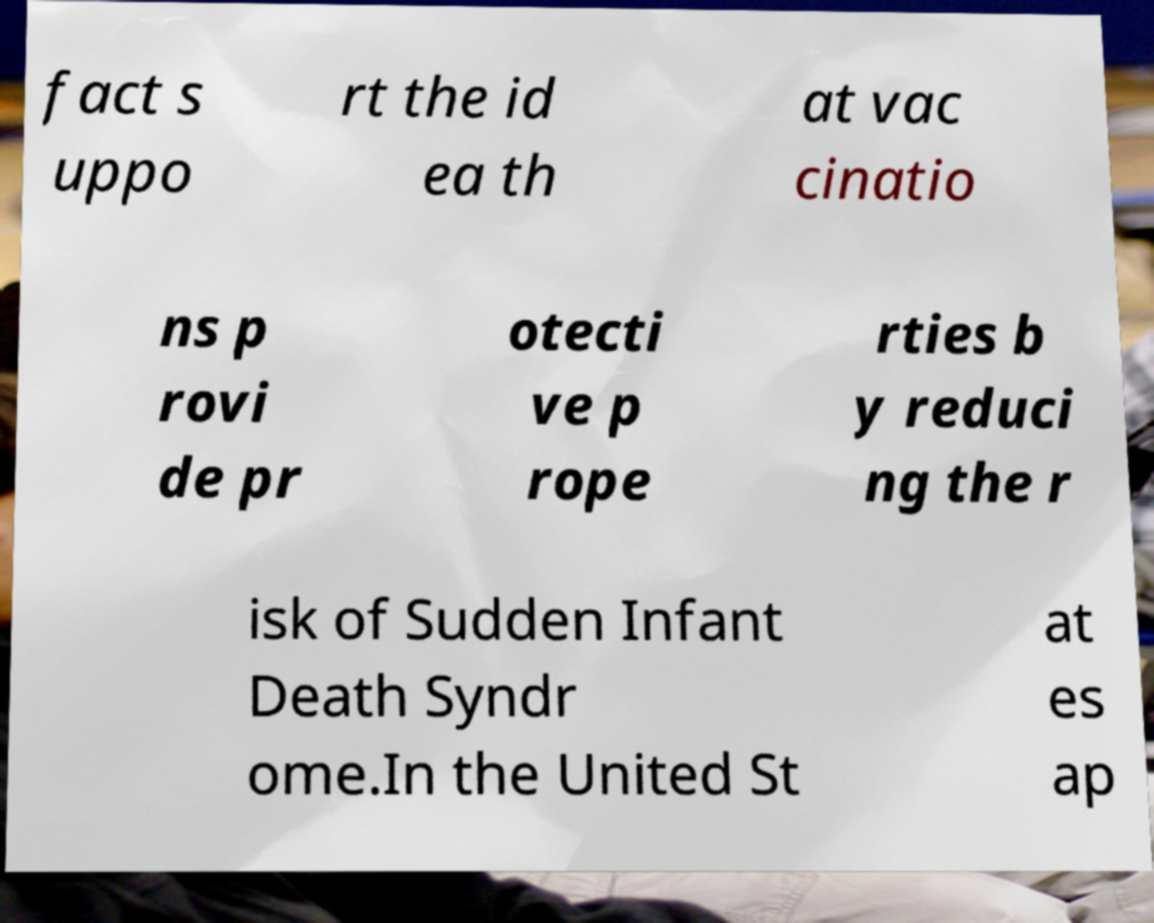There's text embedded in this image that I need extracted. Can you transcribe it verbatim? fact s uppo rt the id ea th at vac cinatio ns p rovi de pr otecti ve p rope rties b y reduci ng the r isk of Sudden Infant Death Syndr ome.In the United St at es ap 